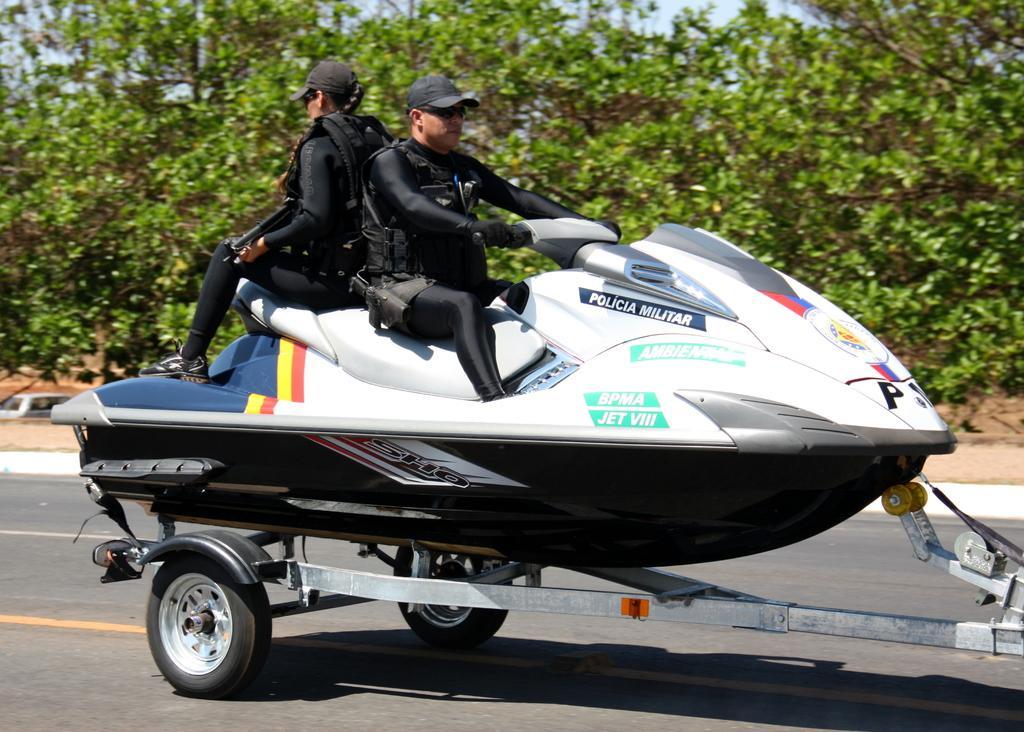Can you describe this image briefly? In this image, I can see two persons sitting on a jet ski, which is on a wheel cart. I can see a wheel cart on the road. In the background there are trees and the sky. 